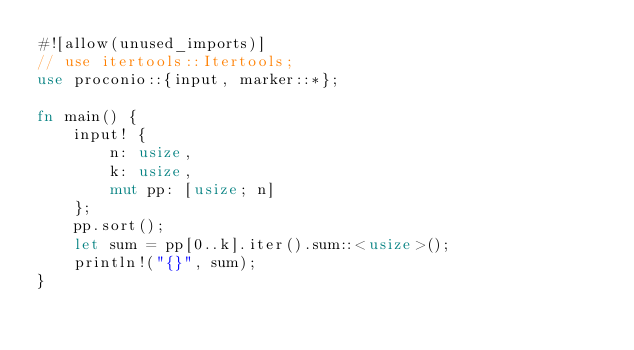Convert code to text. <code><loc_0><loc_0><loc_500><loc_500><_Rust_>#![allow(unused_imports)]
// use itertools::Itertools;
use proconio::{input, marker::*};

fn main() {
    input! {
        n: usize,
        k: usize,
        mut pp: [usize; n]
    };
    pp.sort();
    let sum = pp[0..k].iter().sum::<usize>();
    println!("{}", sum);
}
</code> 